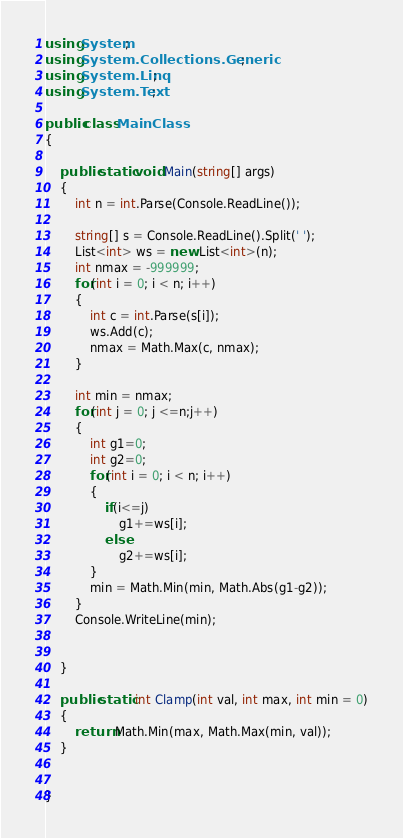Convert code to text. <code><loc_0><loc_0><loc_500><loc_500><_C#_>using System;
using System.Collections.Generic;
using System.Linq;
using System.Text;

public class MainClass
{

	public static void Main(string[] args)
	{
		int n = int.Parse(Console.ReadLine());
	
		string[] s = Console.ReadLine().Split(' ');
		List<int> ws = new List<int>(n);
		int nmax = -999999;
		for(int i = 0; i < n; i++)
		{
			int c = int.Parse(s[i]);
			ws.Add(c);
			nmax = Math.Max(c, nmax);
		}
		
		int min = nmax;
		for(int j = 0; j <=n;j++)
		{
			int g1=0;
			int g2=0;
			for(int i = 0; i < n; i++)
			{
				if(i<=j)
					g1+=ws[i];
				else
					g2+=ws[i];
			}
			min = Math.Min(min, Math.Abs(g1-g2));
		}
		Console.WriteLine(min);
	
		
	}

	public static int Clamp(int val, int max, int min = 0)
	{
		return Math.Min(max, Math.Max(min, val));
	}

	
}

</code> 